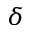Convert formula to latex. <formula><loc_0><loc_0><loc_500><loc_500>\delta</formula> 